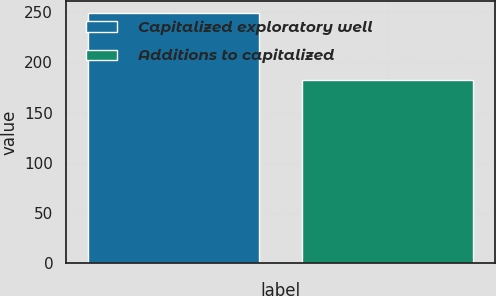Convert chart. <chart><loc_0><loc_0><loc_500><loc_500><bar_chart><fcel>Capitalized exploratory well<fcel>Additions to capitalized<nl><fcel>249<fcel>182<nl></chart> 